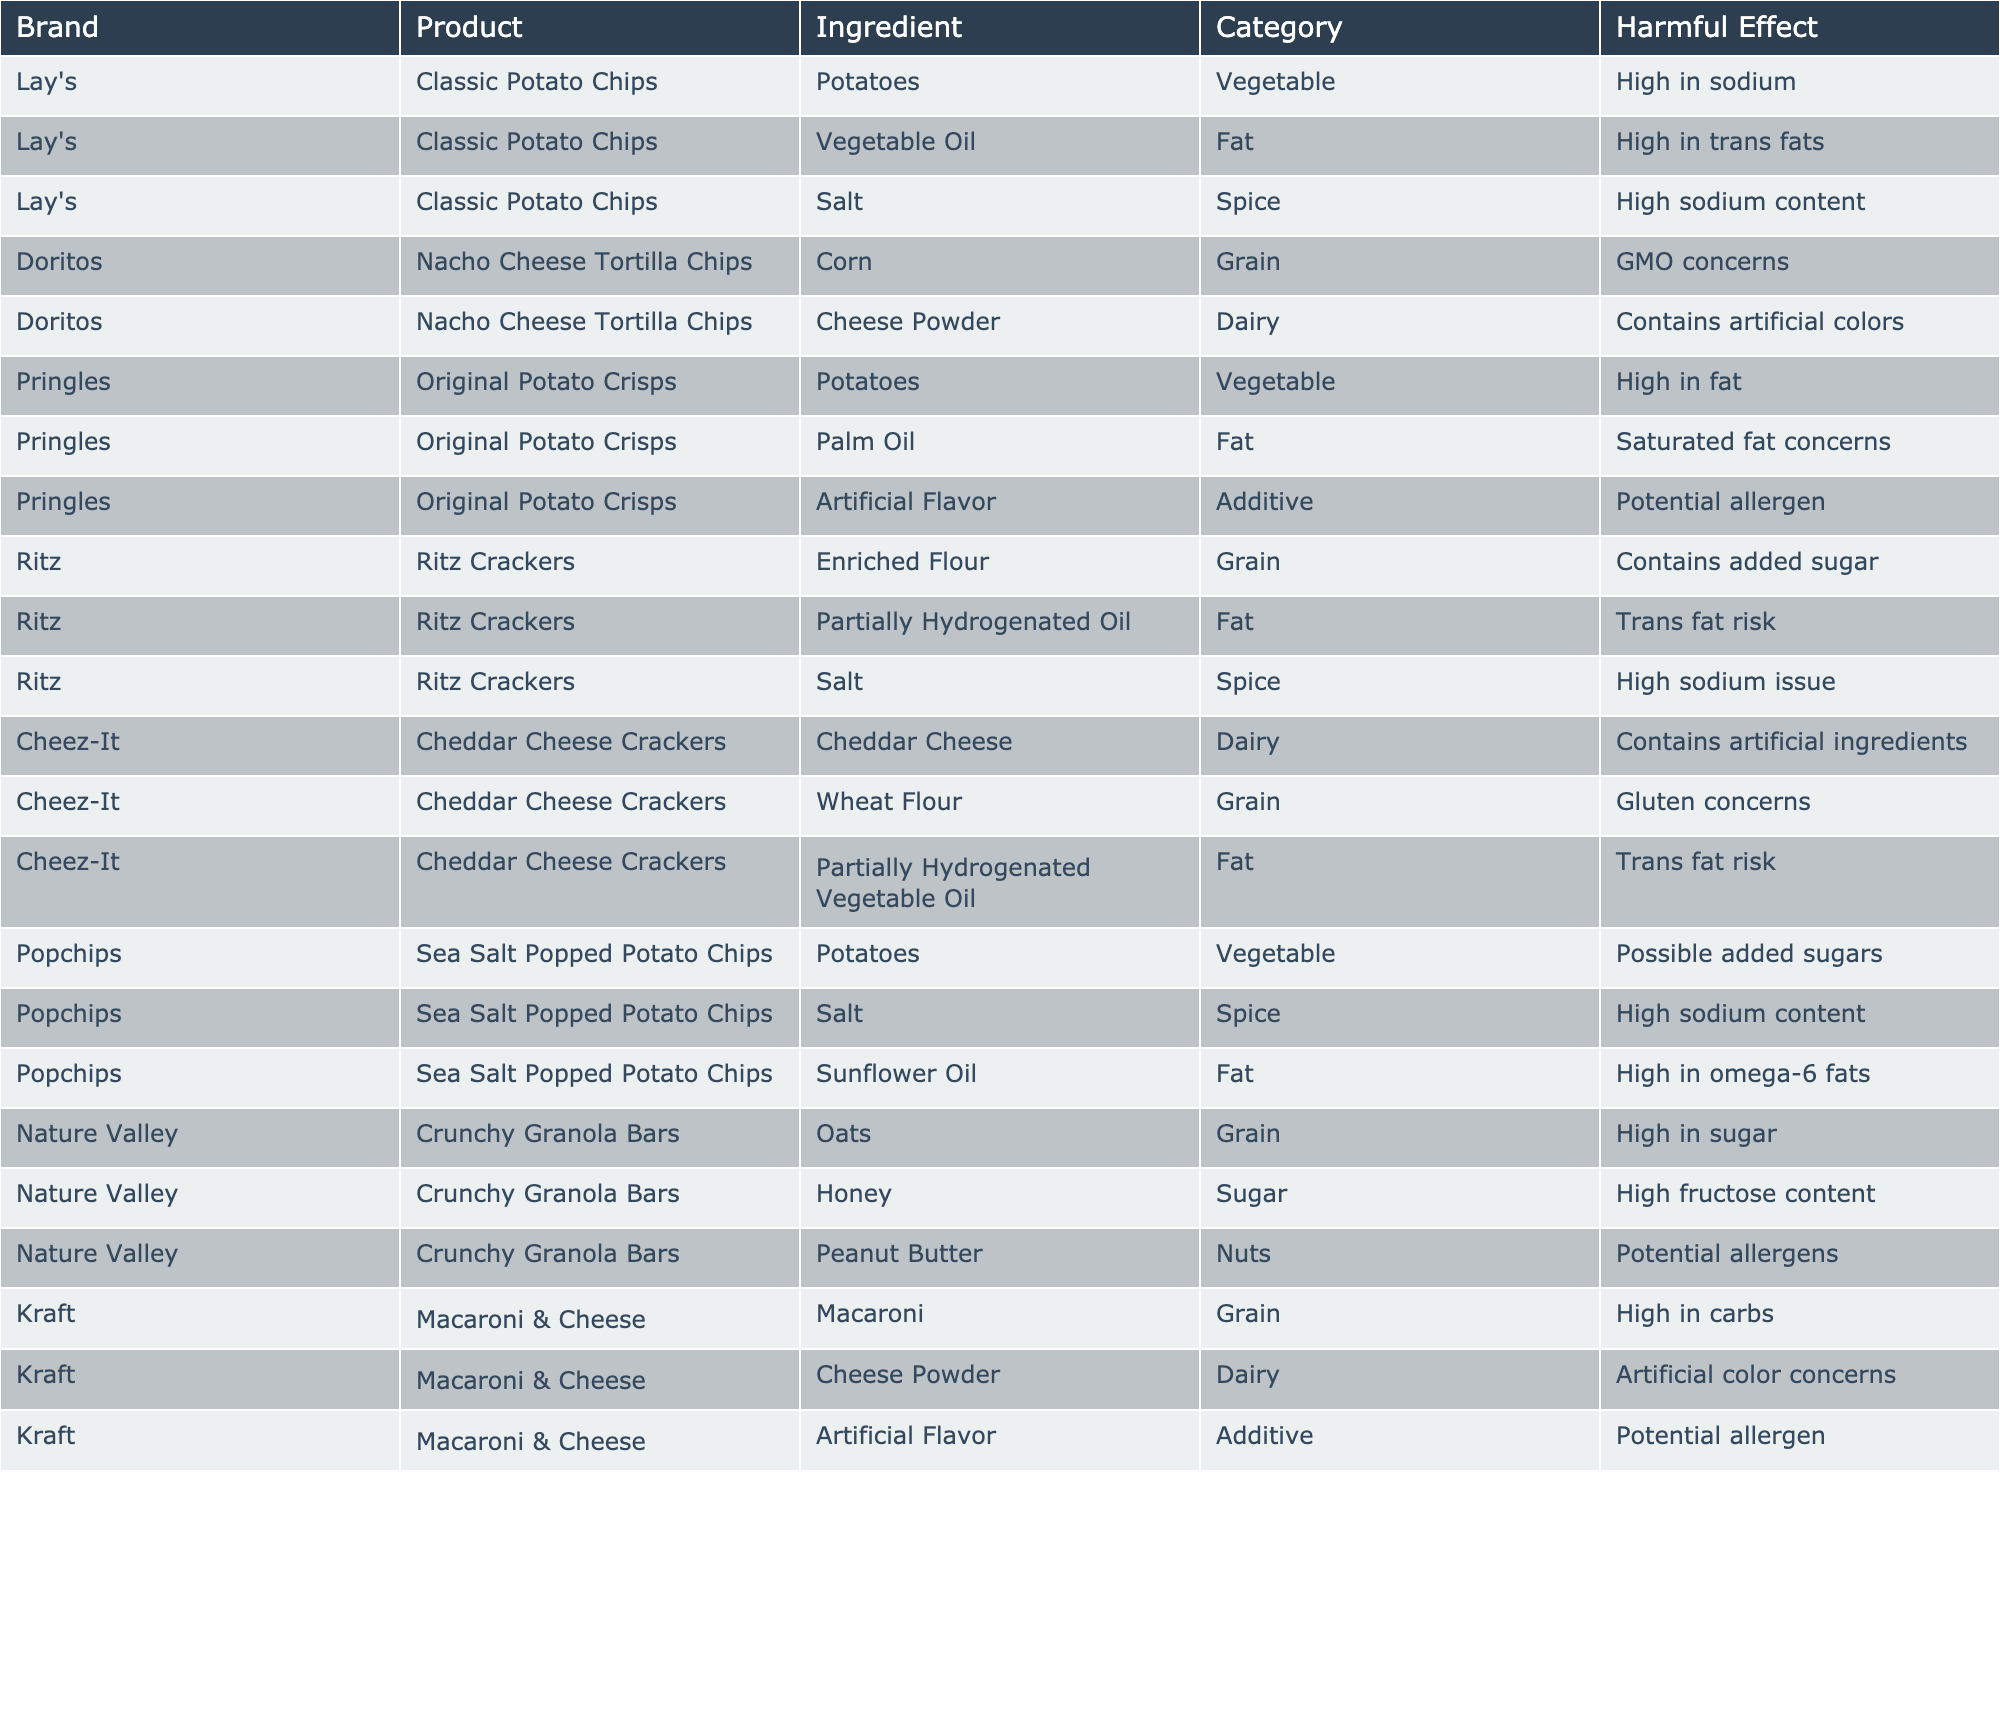What snack contains the highest sodium content? By examining the table, "Lay's Classic Potato Chips" contains salt, which is specifically noted for its high sodium content. This is the only snack explicitly identified for high sodium among others.
Answer: Lay's Classic Potato Chips Which product has the most harmful effects listed? The product "Cheez-It Cheddar Cheese Crackers" has the highest number of harmful effects, with three listed: artificial ingredients, gluten concerns, and trans fat risk.
Answer: Cheez-It Cheddar Cheese Crackers Are there any snacks that contain artificial flavors? Yes, "Pringles Original Potato Crisps" and "Kraft Macaroni & Cheese" both contain artificial flavors as stated in their ingredient lists.
Answer: Yes How many products contain palm oil? There is one product, "Pringles Original Potato Crisps," noted for containing palm oil. This is the only entry for palm oil in the table.
Answer: 1 What's the average harmful effect count per product? There are 12 products listed and a total of 14 harmful effects identified. Calculating the average gives 14/12 = 1.17, which means on average, each product has about 1.17 harmful effects.
Answer: 1.17 Do all products contain either fat or sugar? Yes, upon reviewing the table, each product lists either fat or sugar in their ingredients, confirming that all products contain these components.
Answer: Yes Which snack has GMO concerns? According to the table, "Doritos Nacho Cheese Tortilla Chips" is the snack that has GMO concerns marked as a harmful effect.
Answer: Doritos Nacho Cheese Tortilla Chips What is the total number of dairy ingredients present in the table? The dairy ingredients listed include cheese powder from "Kraft Macaroni & Cheese," "Doritos Nacho Cheese Tortilla Chips," and "Cheez-It Cheddar Cheese Crackers." Therefore, the total is three dairy ingredients.
Answer: 3 Is there a product that is high in omega-6 fats? Yes, "Popchips Sea Salt Popped Potato Chips" specifies high omega-6 fats as a harmful effect, indicating this product contains such fats.
Answer: Yes Which two snacks are associated with trans fat risks? Both "Ritz Crackers" and "Cheez-It Cheddar Cheese Crackers" list partially hydrogenated oil as an ingredient, leading to trans fat risks for those products.
Answer: Ritz Crackers, Cheez-It Cheddar Cheese Crackers 